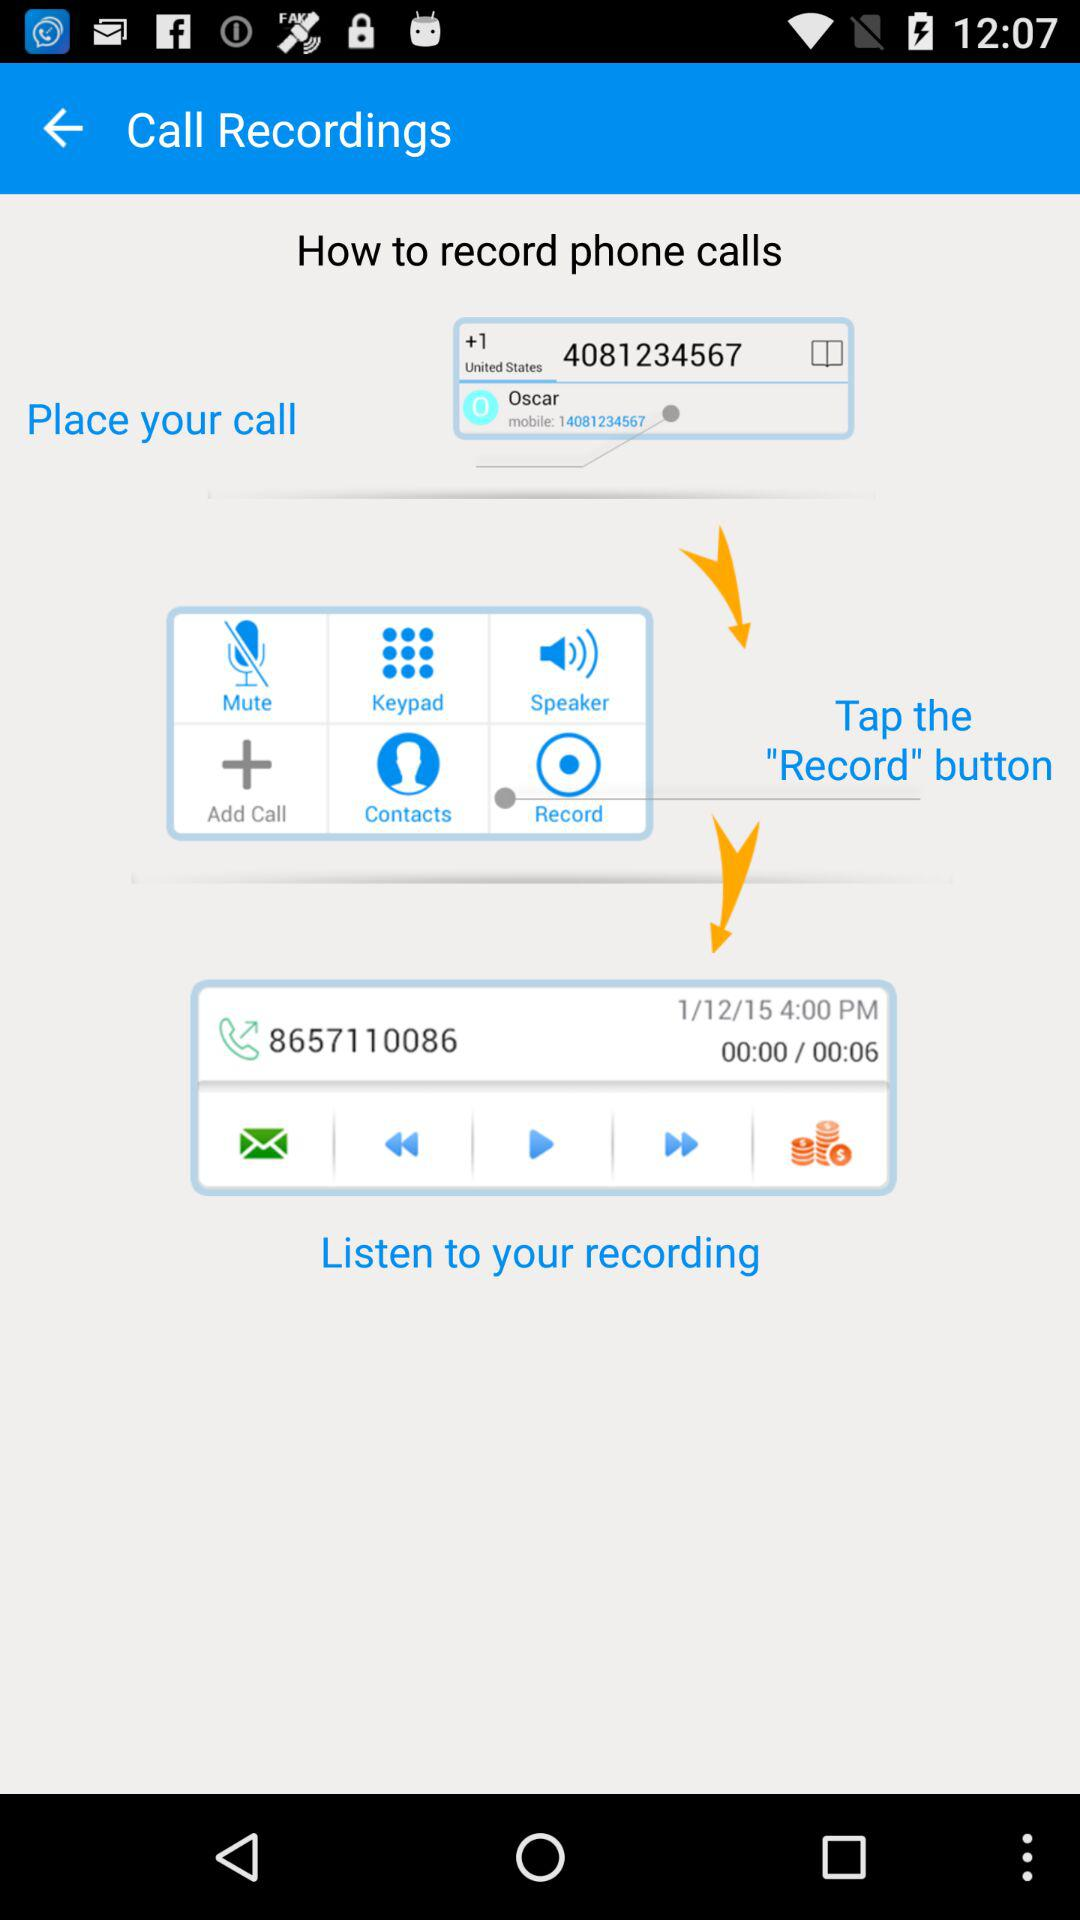What are the steps to follow to record a phone call? The steps are "Place your call", "Tap the "Record" button" and "Listen to your recording". 